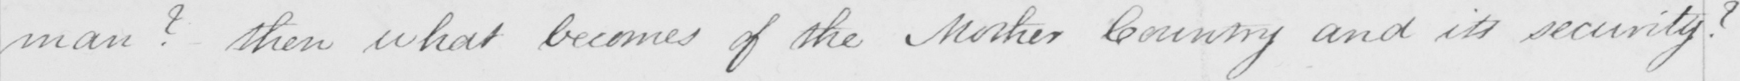What text is written in this handwritten line? man ?  Then what becomes of the Mother Country and its security ? 